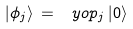Convert formula to latex. <formula><loc_0><loc_0><loc_500><loc_500>| \phi _ { j } \rangle \, = \, \ y o p _ { j } \, | 0 \rangle</formula> 